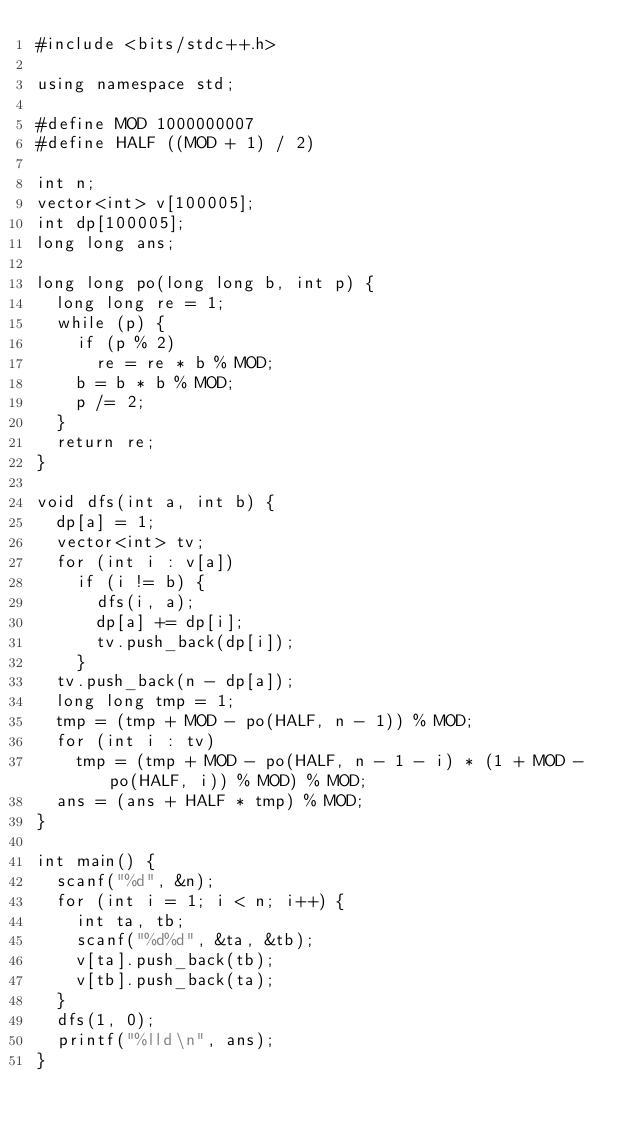Convert code to text. <code><loc_0><loc_0><loc_500><loc_500><_C++_>#include <bits/stdc++.h>

using namespace std;

#define MOD 1000000007
#define HALF ((MOD + 1) / 2)

int n;
vector<int> v[100005];
int dp[100005];
long long ans;

long long po(long long b, int p) {
	long long re = 1;
	while (p) {
		if (p % 2)
			re = re * b % MOD;
		b = b * b % MOD;
		p /= 2;
	}
	return re;
}

void dfs(int a, int b) {
	dp[a] = 1;
	vector<int> tv;
	for (int i : v[a])
		if (i != b) {
			dfs(i, a);
			dp[a] += dp[i];
			tv.push_back(dp[i]);
		}
	tv.push_back(n - dp[a]);
	long long tmp = 1;
	tmp = (tmp + MOD - po(HALF, n - 1)) % MOD;
	for (int i : tv)
		tmp = (tmp + MOD - po(HALF, n - 1 - i) * (1 + MOD - po(HALF, i)) % MOD) % MOD;
	ans = (ans + HALF * tmp) % MOD;
}

int main() {
	scanf("%d", &n);
	for (int i = 1; i < n; i++) {
		int ta, tb;
		scanf("%d%d", &ta, &tb);
		v[ta].push_back(tb);
		v[tb].push_back(ta);
	}
	dfs(1, 0);
	printf("%lld\n", ans);
}</code> 